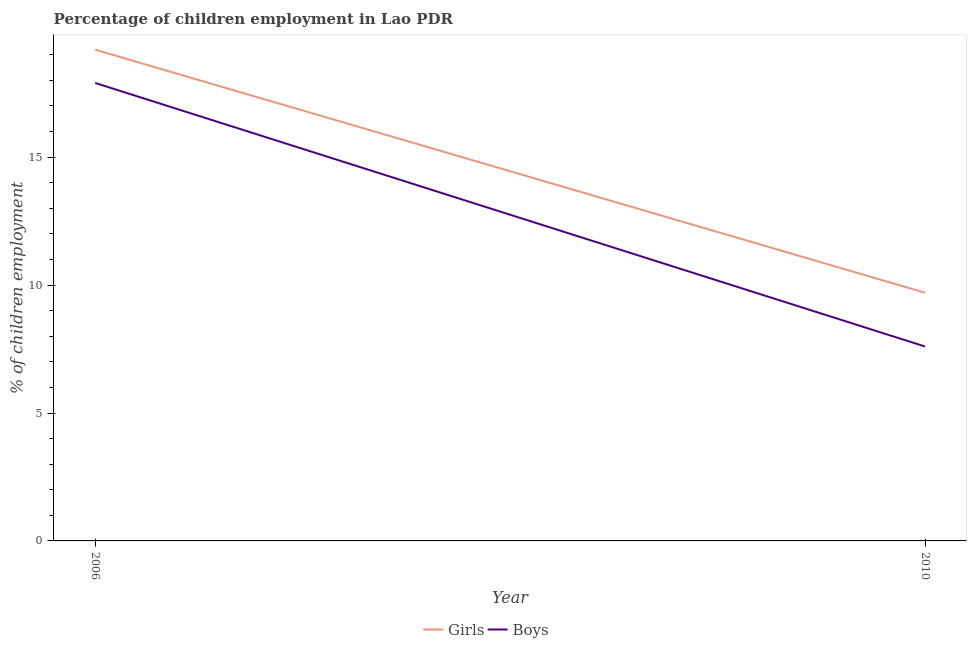Across all years, what is the maximum percentage of employed boys?
Make the answer very short. 17.9. Across all years, what is the minimum percentage of employed girls?
Provide a short and direct response. 9.7. What is the total percentage of employed boys in the graph?
Give a very brief answer. 25.5. What is the difference between the percentage of employed boys in 2006 and that in 2010?
Provide a succinct answer. 10.3. What is the average percentage of employed boys per year?
Your response must be concise. 12.75. In the year 2006, what is the difference between the percentage of employed girls and percentage of employed boys?
Provide a succinct answer. 1.3. What is the ratio of the percentage of employed boys in 2006 to that in 2010?
Ensure brevity in your answer.  2.36. Is the percentage of employed girls strictly less than the percentage of employed boys over the years?
Ensure brevity in your answer.  No. How many lines are there?
Your answer should be compact. 2. How many years are there in the graph?
Your response must be concise. 2. What is the difference between two consecutive major ticks on the Y-axis?
Ensure brevity in your answer.  5. Are the values on the major ticks of Y-axis written in scientific E-notation?
Keep it short and to the point. No. Does the graph contain any zero values?
Provide a short and direct response. No. Does the graph contain grids?
Make the answer very short. No. How many legend labels are there?
Offer a terse response. 2. How are the legend labels stacked?
Offer a very short reply. Horizontal. What is the title of the graph?
Your response must be concise. Percentage of children employment in Lao PDR. What is the label or title of the X-axis?
Ensure brevity in your answer.  Year. What is the label or title of the Y-axis?
Offer a very short reply. % of children employment. What is the % of children employment of Girls in 2006?
Offer a terse response. 19.2. What is the % of children employment in Girls in 2010?
Give a very brief answer. 9.7. What is the % of children employment of Boys in 2010?
Your answer should be very brief. 7.6. Across all years, what is the maximum % of children employment in Girls?
Provide a short and direct response. 19.2. Across all years, what is the maximum % of children employment in Boys?
Ensure brevity in your answer.  17.9. What is the total % of children employment in Girls in the graph?
Your response must be concise. 28.9. What is the total % of children employment in Boys in the graph?
Provide a short and direct response. 25.5. What is the average % of children employment in Girls per year?
Provide a succinct answer. 14.45. What is the average % of children employment in Boys per year?
Keep it short and to the point. 12.75. In the year 2006, what is the difference between the % of children employment of Girls and % of children employment of Boys?
Provide a succinct answer. 1.3. What is the ratio of the % of children employment in Girls in 2006 to that in 2010?
Your response must be concise. 1.98. What is the ratio of the % of children employment in Boys in 2006 to that in 2010?
Your response must be concise. 2.36. What is the difference between the highest and the second highest % of children employment of Boys?
Offer a terse response. 10.3. What is the difference between the highest and the lowest % of children employment in Girls?
Your answer should be compact. 9.5. 